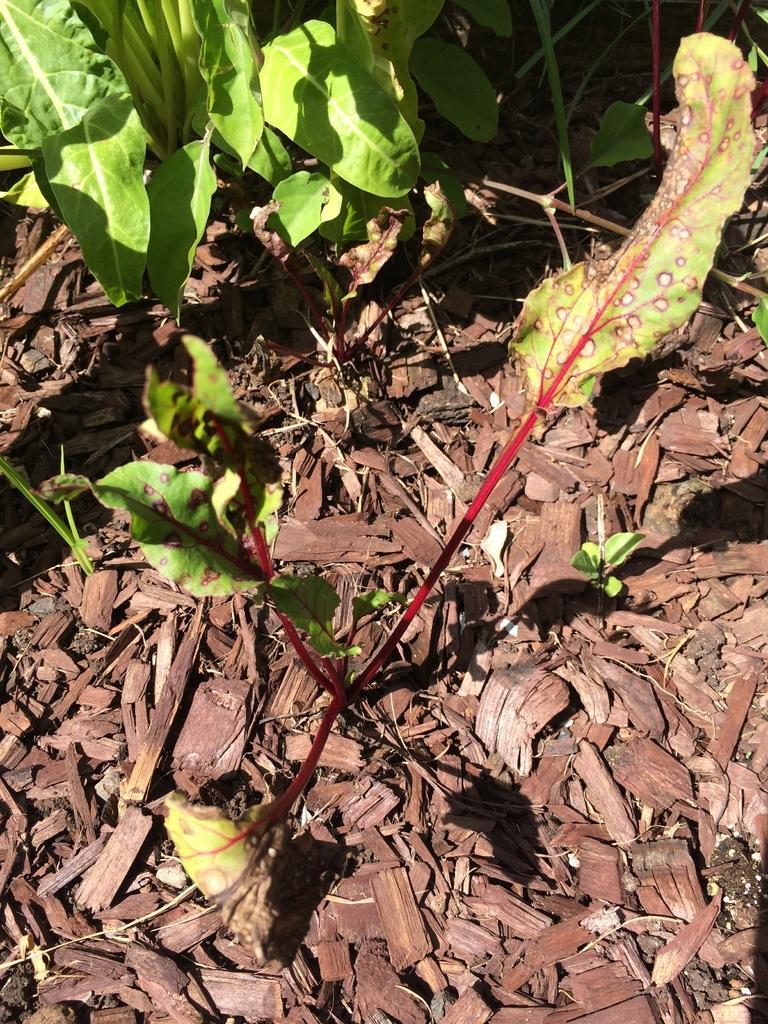How would you summarize this image in a sentence or two? In this image, we can see a some plants with green leaves. At the bottom, we can see a land with some leaves. 